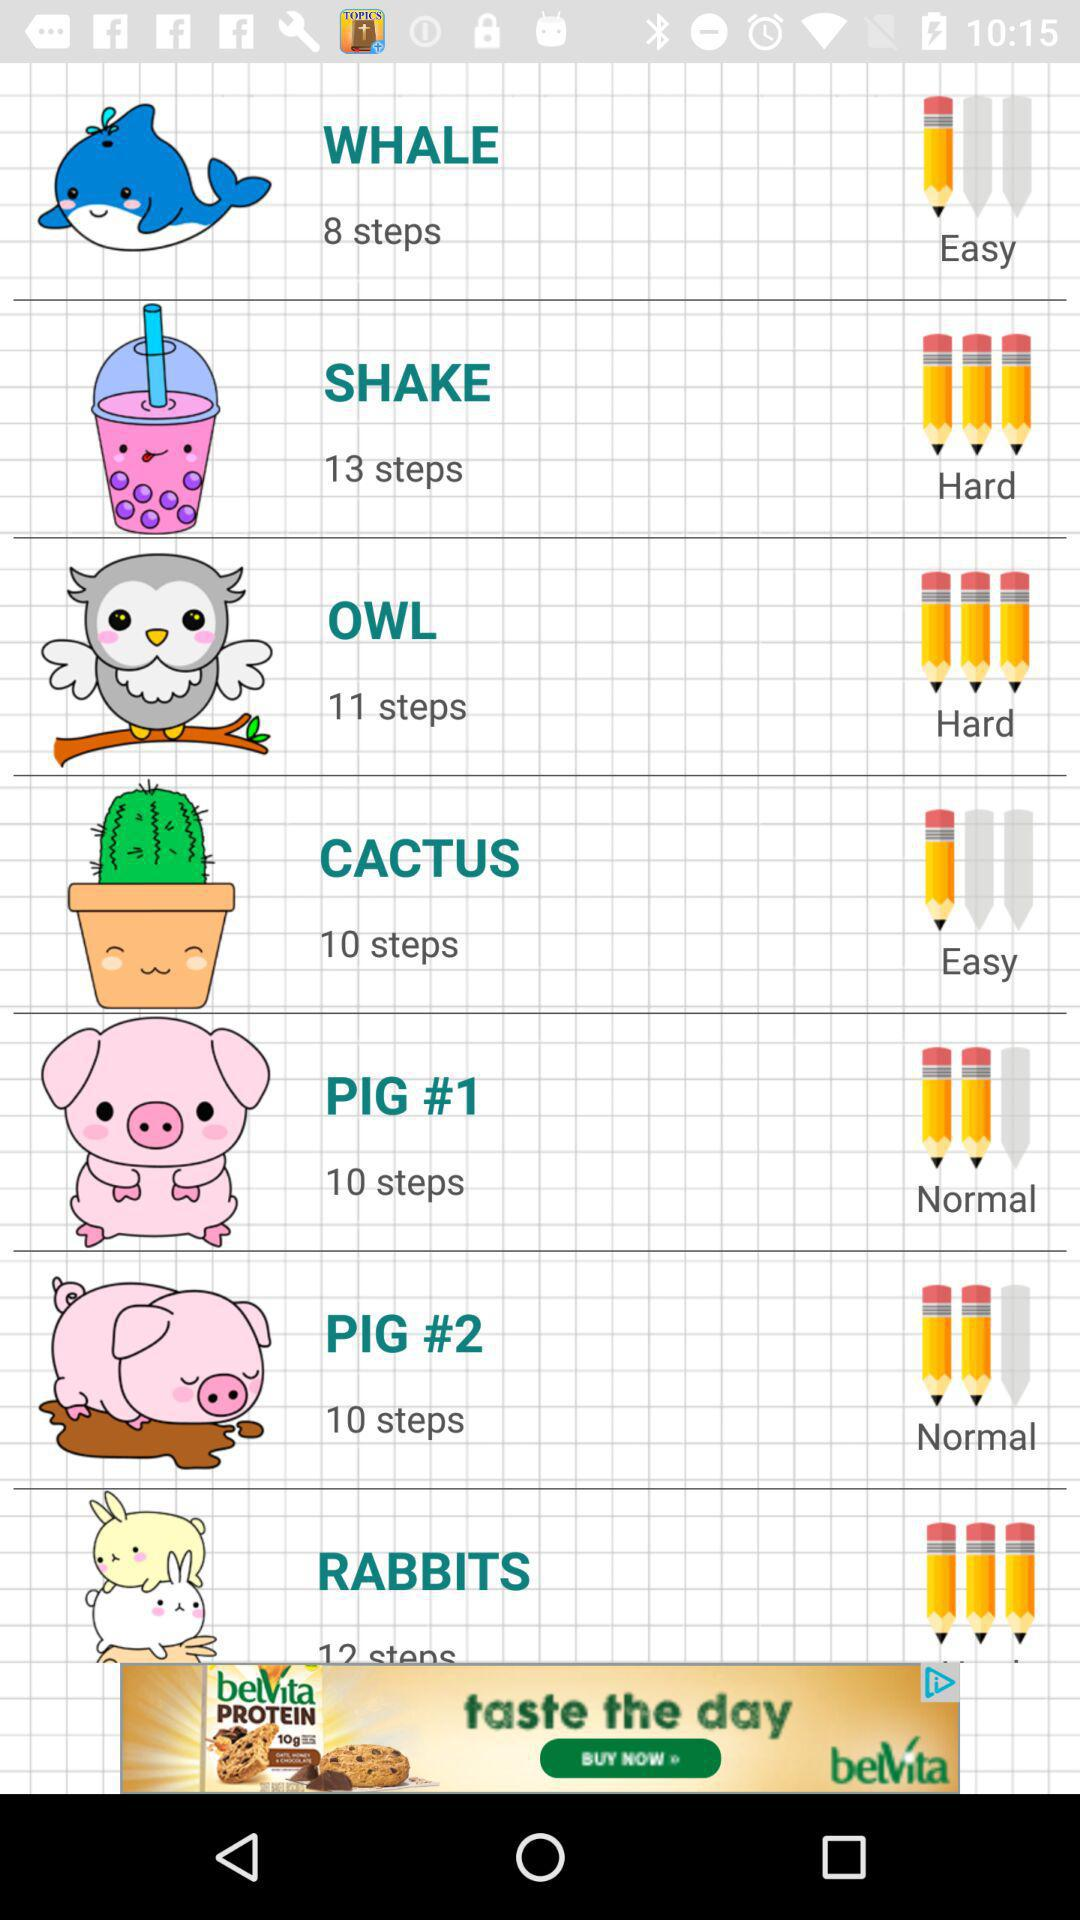How many steps are there in a whale? There are 8 steps in a whale. 